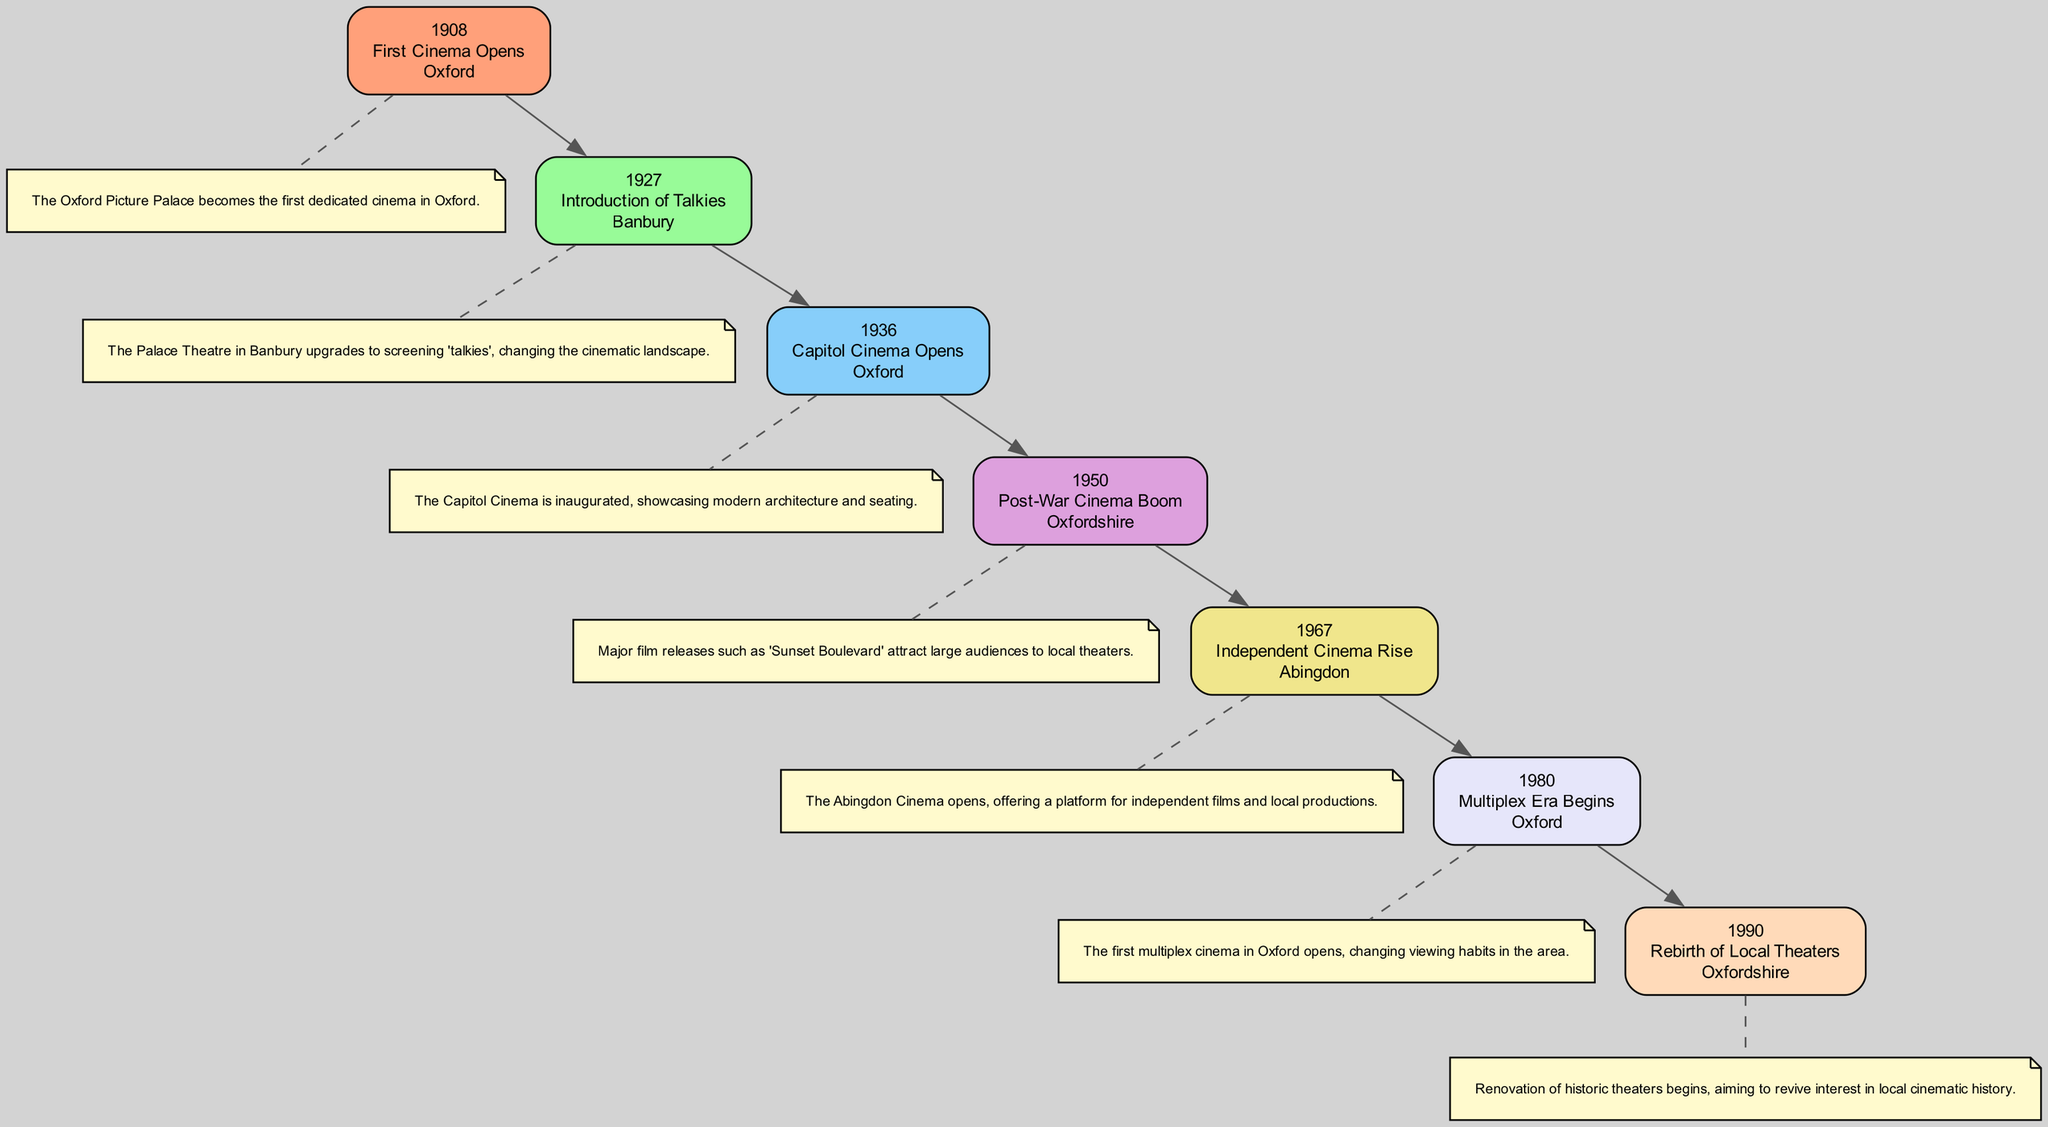What year did the first cinema open in Oxford? The diagram indicates that the first cinema, the Oxford Picture Palace, opened in 1908. This is shown in the first event node.
Answer: 1908 Which location saw the introduction of talkies in 1927? The diagram highlights that the Palace Theatre in Banbury was the location that upgraded to screening 'talkies' in 1927. This is specified in the corresponding event node.
Answer: Banbury How many events are listed in the diagram? By counting the event nodes shown in the diagram, there are a total of seven significant events listed from 1908 to 1990.
Answer: 7 What is the last event mentioned in the diagram? The final event node in the diagram describes the renovation of historic theaters beginning in 1990, marking a focus on reviving local cinematic history.
Answer: Rebirth of Local Theaters Which event marks the beginning of the multiplex era? According to the diagram, the beginning of the multiplex era is marked by the opening of the first multiplex cinema in Oxford in 1980.
Answer: Multiplex Era Begins What is a notable change in cinema that occurred in 1950? The diagram indicates that 1950 saw a post-war cinema boom, with major film releases like 'Sunset Boulevard' drawing large audiences, marking a significant change in local cinema attendance.
Answer: Post-War Cinema Boom Which cinema in Abingdon offered a platform for independent films? As per the diagram, the Abingdon Cinema, which opened in 1967, was the venue that provided support for independent films and local productions.
Answer: Abingdon Cinema What relationship exists between the 1936 event and the 1950 event? The diagram shows that the Capitol Cinema's opening in 1936 led to the flourishing cinema environment in Oxfordshire, culminating in the post-war boom and the increased audience attendance noted in the 1950 event.
Answer: 1936 led to 1950's boom Which color represents the 1967 event in the diagram? The diagram uses a specific color scheme for its nodes, and the 1967 event regarding independent cinema is represented by a light lavender color, corresponding to the fifth node.
Answer: Light lavender 